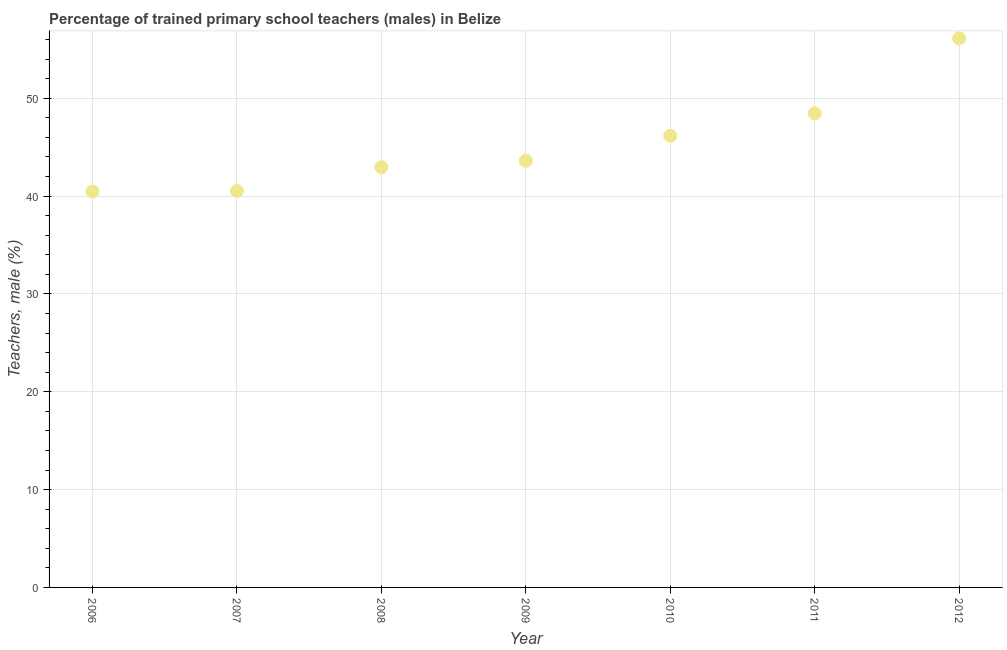What is the percentage of trained male teachers in 2007?
Provide a succinct answer. 40.53. Across all years, what is the maximum percentage of trained male teachers?
Provide a succinct answer. 56.11. Across all years, what is the minimum percentage of trained male teachers?
Keep it short and to the point. 40.46. In which year was the percentage of trained male teachers maximum?
Give a very brief answer. 2012. What is the sum of the percentage of trained male teachers?
Your response must be concise. 318.26. What is the difference between the percentage of trained male teachers in 2007 and 2011?
Give a very brief answer. -7.92. What is the average percentage of trained male teachers per year?
Your answer should be very brief. 45.47. What is the median percentage of trained male teachers?
Your answer should be compact. 43.6. What is the ratio of the percentage of trained male teachers in 2007 to that in 2008?
Your response must be concise. 0.94. Is the percentage of trained male teachers in 2006 less than that in 2009?
Make the answer very short. Yes. Is the difference between the percentage of trained male teachers in 2007 and 2009 greater than the difference between any two years?
Give a very brief answer. No. What is the difference between the highest and the second highest percentage of trained male teachers?
Your response must be concise. 7.66. What is the difference between the highest and the lowest percentage of trained male teachers?
Your answer should be compact. 15.65. Does the percentage of trained male teachers monotonically increase over the years?
Keep it short and to the point. Yes. How many dotlines are there?
Offer a very short reply. 1. What is the difference between two consecutive major ticks on the Y-axis?
Give a very brief answer. 10. Are the values on the major ticks of Y-axis written in scientific E-notation?
Offer a very short reply. No. Does the graph contain any zero values?
Ensure brevity in your answer.  No. What is the title of the graph?
Offer a very short reply. Percentage of trained primary school teachers (males) in Belize. What is the label or title of the Y-axis?
Offer a terse response. Teachers, male (%). What is the Teachers, male (%) in 2006?
Provide a succinct answer. 40.46. What is the Teachers, male (%) in 2007?
Make the answer very short. 40.53. What is the Teachers, male (%) in 2008?
Give a very brief answer. 42.95. What is the Teachers, male (%) in 2009?
Offer a terse response. 43.6. What is the Teachers, male (%) in 2010?
Your response must be concise. 46.17. What is the Teachers, male (%) in 2011?
Your answer should be very brief. 48.44. What is the Teachers, male (%) in 2012?
Make the answer very short. 56.11. What is the difference between the Teachers, male (%) in 2006 and 2007?
Provide a succinct answer. -0.07. What is the difference between the Teachers, male (%) in 2006 and 2008?
Keep it short and to the point. -2.49. What is the difference between the Teachers, male (%) in 2006 and 2009?
Keep it short and to the point. -3.14. What is the difference between the Teachers, male (%) in 2006 and 2010?
Provide a short and direct response. -5.71. What is the difference between the Teachers, male (%) in 2006 and 2011?
Your response must be concise. -7.98. What is the difference between the Teachers, male (%) in 2006 and 2012?
Ensure brevity in your answer.  -15.65. What is the difference between the Teachers, male (%) in 2007 and 2008?
Your response must be concise. -2.42. What is the difference between the Teachers, male (%) in 2007 and 2009?
Offer a very short reply. -3.08. What is the difference between the Teachers, male (%) in 2007 and 2010?
Offer a terse response. -5.64. What is the difference between the Teachers, male (%) in 2007 and 2011?
Give a very brief answer. -7.92. What is the difference between the Teachers, male (%) in 2007 and 2012?
Ensure brevity in your answer.  -15.58. What is the difference between the Teachers, male (%) in 2008 and 2009?
Your response must be concise. -0.65. What is the difference between the Teachers, male (%) in 2008 and 2010?
Your response must be concise. -3.22. What is the difference between the Teachers, male (%) in 2008 and 2011?
Your response must be concise. -5.49. What is the difference between the Teachers, male (%) in 2008 and 2012?
Make the answer very short. -13.15. What is the difference between the Teachers, male (%) in 2009 and 2010?
Your answer should be very brief. -2.56. What is the difference between the Teachers, male (%) in 2009 and 2011?
Your response must be concise. -4.84. What is the difference between the Teachers, male (%) in 2009 and 2012?
Make the answer very short. -12.5. What is the difference between the Teachers, male (%) in 2010 and 2011?
Keep it short and to the point. -2.28. What is the difference between the Teachers, male (%) in 2010 and 2012?
Give a very brief answer. -9.94. What is the difference between the Teachers, male (%) in 2011 and 2012?
Your response must be concise. -7.66. What is the ratio of the Teachers, male (%) in 2006 to that in 2008?
Make the answer very short. 0.94. What is the ratio of the Teachers, male (%) in 2006 to that in 2009?
Your answer should be compact. 0.93. What is the ratio of the Teachers, male (%) in 2006 to that in 2010?
Your answer should be very brief. 0.88. What is the ratio of the Teachers, male (%) in 2006 to that in 2011?
Offer a terse response. 0.83. What is the ratio of the Teachers, male (%) in 2006 to that in 2012?
Your response must be concise. 0.72. What is the ratio of the Teachers, male (%) in 2007 to that in 2008?
Your answer should be very brief. 0.94. What is the ratio of the Teachers, male (%) in 2007 to that in 2009?
Your answer should be compact. 0.93. What is the ratio of the Teachers, male (%) in 2007 to that in 2010?
Offer a very short reply. 0.88. What is the ratio of the Teachers, male (%) in 2007 to that in 2011?
Your answer should be compact. 0.84. What is the ratio of the Teachers, male (%) in 2007 to that in 2012?
Make the answer very short. 0.72. What is the ratio of the Teachers, male (%) in 2008 to that in 2011?
Your answer should be compact. 0.89. What is the ratio of the Teachers, male (%) in 2008 to that in 2012?
Give a very brief answer. 0.77. What is the ratio of the Teachers, male (%) in 2009 to that in 2010?
Your answer should be very brief. 0.94. What is the ratio of the Teachers, male (%) in 2009 to that in 2011?
Provide a succinct answer. 0.9. What is the ratio of the Teachers, male (%) in 2009 to that in 2012?
Provide a short and direct response. 0.78. What is the ratio of the Teachers, male (%) in 2010 to that in 2011?
Offer a very short reply. 0.95. What is the ratio of the Teachers, male (%) in 2010 to that in 2012?
Your answer should be compact. 0.82. What is the ratio of the Teachers, male (%) in 2011 to that in 2012?
Provide a short and direct response. 0.86. 